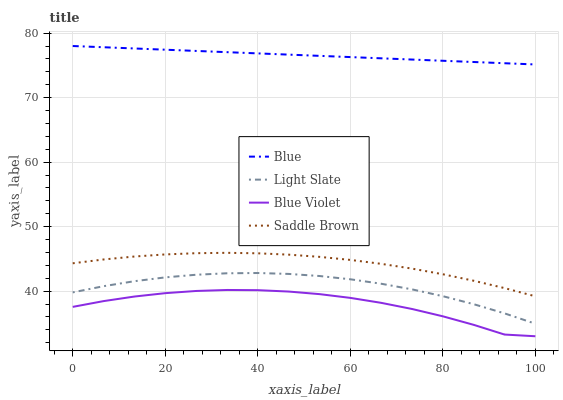Does Blue Violet have the minimum area under the curve?
Answer yes or no. Yes. Does Blue have the maximum area under the curve?
Answer yes or no. Yes. Does Light Slate have the minimum area under the curve?
Answer yes or no. No. Does Light Slate have the maximum area under the curve?
Answer yes or no. No. Is Blue the smoothest?
Answer yes or no. Yes. Is Blue Violet the roughest?
Answer yes or no. Yes. Is Light Slate the smoothest?
Answer yes or no. No. Is Light Slate the roughest?
Answer yes or no. No. Does Blue Violet have the lowest value?
Answer yes or no. Yes. Does Light Slate have the lowest value?
Answer yes or no. No. Does Blue have the highest value?
Answer yes or no. Yes. Does Light Slate have the highest value?
Answer yes or no. No. Is Blue Violet less than Saddle Brown?
Answer yes or no. Yes. Is Saddle Brown greater than Blue Violet?
Answer yes or no. Yes. Does Blue Violet intersect Saddle Brown?
Answer yes or no. No. 